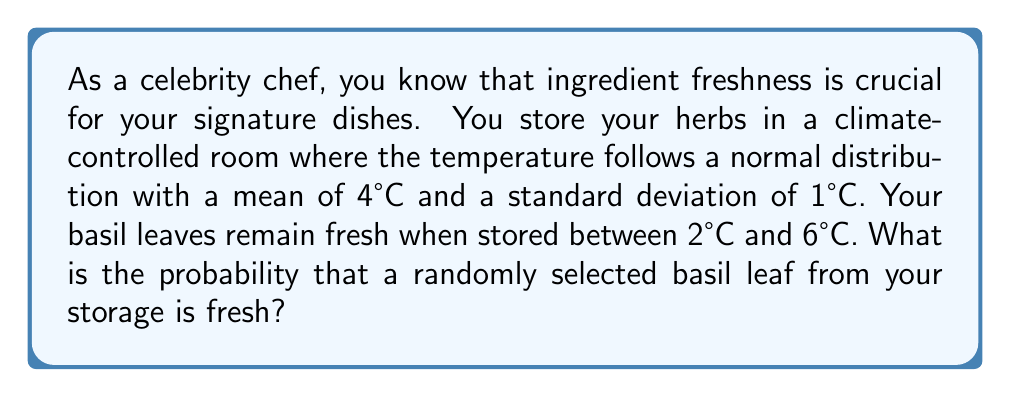Teach me how to tackle this problem. To solve this problem, we need to use the properties of the normal distribution and calculate the area under the curve between 2°C and 6°C.

Step 1: Identify the given information
- Temperature follows a normal distribution
- Mean (μ) = 4°C
- Standard deviation (σ) = 1°C
- Fresh range: 2°C to 6°C

Step 2: Standardize the temperature range
We need to convert the temperature range to z-scores:
For 2°C: $z_1 = \frac{2 - 4}{1} = -2$
For 6°C: $z_2 = \frac{6 - 4}{1} = 2$

Step 3: Use the standard normal distribution table or calculator
We need to find the area under the standard normal curve between z = -2 and z = 2.

This can be calculated as:
$P(-2 \leq z \leq 2) = P(z \leq 2) - P(z \leq -2)$

Using a standard normal table or calculator:
$P(z \leq 2) \approx 0.9772$
$P(z \leq -2) \approx 0.0228$

Step 4: Calculate the probability
$P(-2 \leq z \leq 2) = 0.9772 - 0.0228 = 0.9544$

Therefore, the probability that a randomly selected basil leaf is fresh is approximately 0.9544 or 95.44%.
Answer: 0.9544 